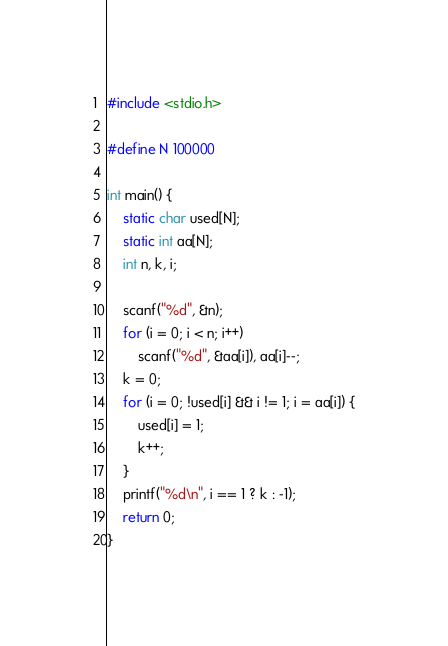Convert code to text. <code><loc_0><loc_0><loc_500><loc_500><_C_>#include <stdio.h>

#define N 100000

int main() {
	static char used[N];
	static int aa[N];
	int n, k, i;

	scanf("%d", &n);
	for (i = 0; i < n; i++)
		scanf("%d", &aa[i]), aa[i]--;
	k = 0;
	for (i = 0; !used[i] && i != 1; i = aa[i]) {
		used[i] = 1;
		k++;
	}
	printf("%d\n", i == 1 ? k : -1);
	return 0;
}
</code> 